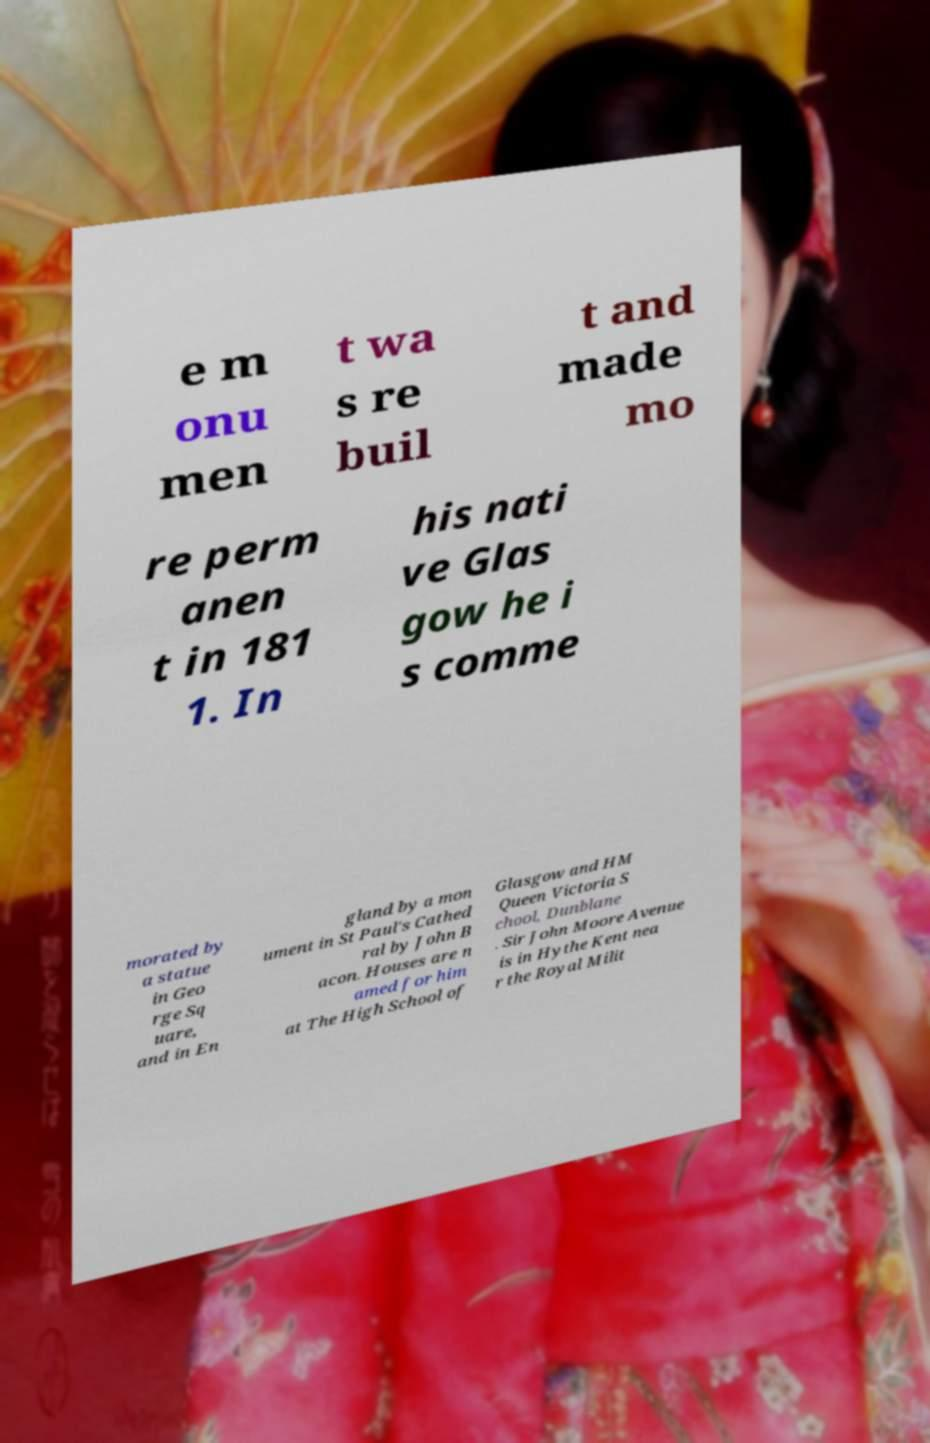For documentation purposes, I need the text within this image transcribed. Could you provide that? e m onu men t wa s re buil t and made mo re perm anen t in 181 1. In his nati ve Glas gow he i s comme morated by a statue in Geo rge Sq uare, and in En gland by a mon ument in St Paul's Cathed ral by John B acon. Houses are n amed for him at The High School of Glasgow and HM Queen Victoria S chool, Dunblane . Sir John Moore Avenue is in Hythe Kent nea r the Royal Milit 